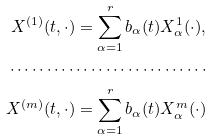Convert formula to latex. <formula><loc_0><loc_0><loc_500><loc_500>X ^ { ( 1 ) } ( t , \cdot ) = \sum _ { \alpha = 1 } ^ { r } b _ { \alpha } ( t ) X ^ { 1 } _ { \alpha } ( \cdot ) , \\ \cdots \cdots \cdots \cdots \cdots \cdots \cdots \cdots \cdots \\ X ^ { ( m ) } ( t , \cdot ) = \sum _ { \alpha = 1 } ^ { r } b _ { \alpha } ( t ) X ^ { m } _ { \alpha } ( \cdot )</formula> 